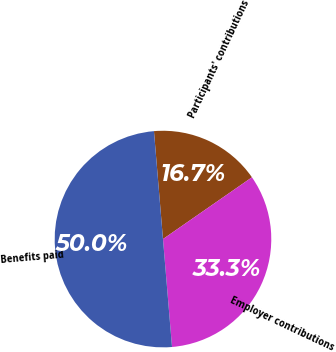<chart> <loc_0><loc_0><loc_500><loc_500><pie_chart><fcel>Participants' contributions<fcel>Employer contributions<fcel>Benefits paid<nl><fcel>16.67%<fcel>33.33%<fcel>50.0%<nl></chart> 